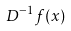Convert formula to latex. <formula><loc_0><loc_0><loc_500><loc_500>D ^ { - 1 } f ( x )</formula> 